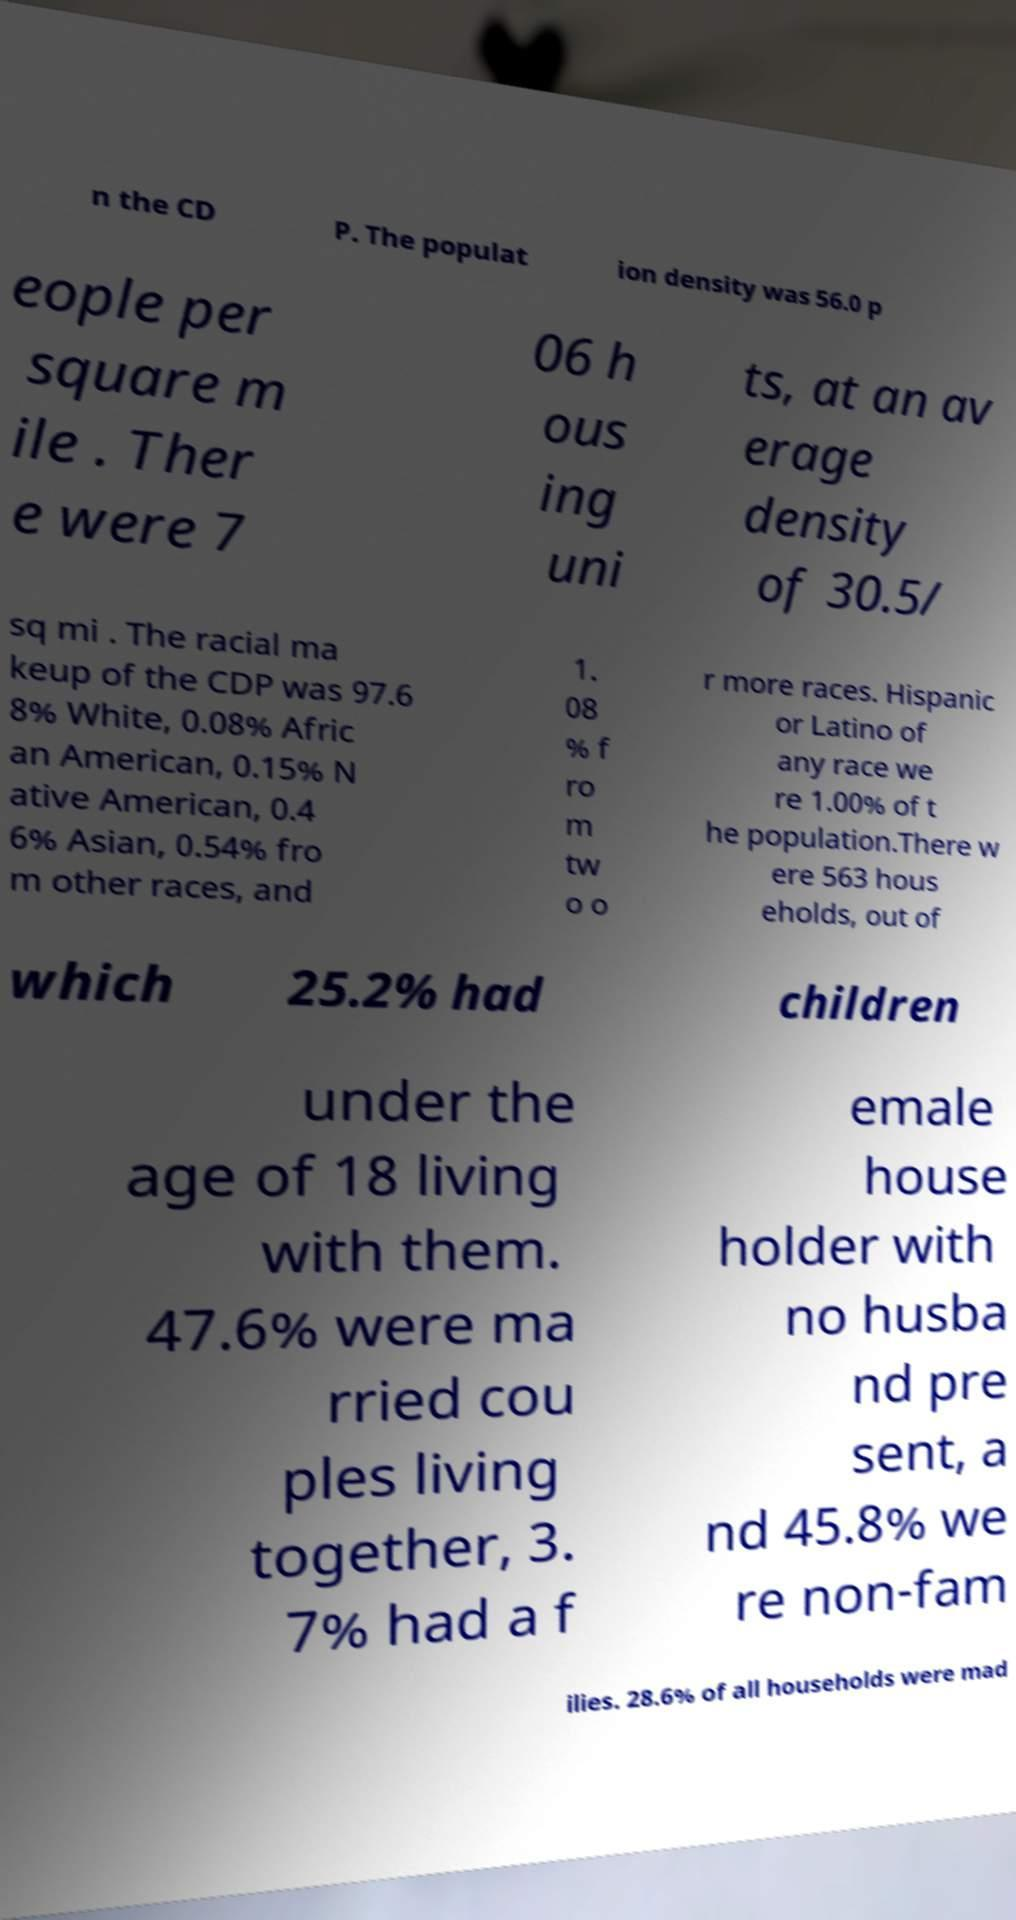For documentation purposes, I need the text within this image transcribed. Could you provide that? n the CD P. The populat ion density was 56.0 p eople per square m ile . Ther e were 7 06 h ous ing uni ts, at an av erage density of 30.5/ sq mi . The racial ma keup of the CDP was 97.6 8% White, 0.08% Afric an American, 0.15% N ative American, 0.4 6% Asian, 0.54% fro m other races, and 1. 08 % f ro m tw o o r more races. Hispanic or Latino of any race we re 1.00% of t he population.There w ere 563 hous eholds, out of which 25.2% had children under the age of 18 living with them. 47.6% were ma rried cou ples living together, 3. 7% had a f emale house holder with no husba nd pre sent, a nd 45.8% we re non-fam ilies. 28.6% of all households were mad 